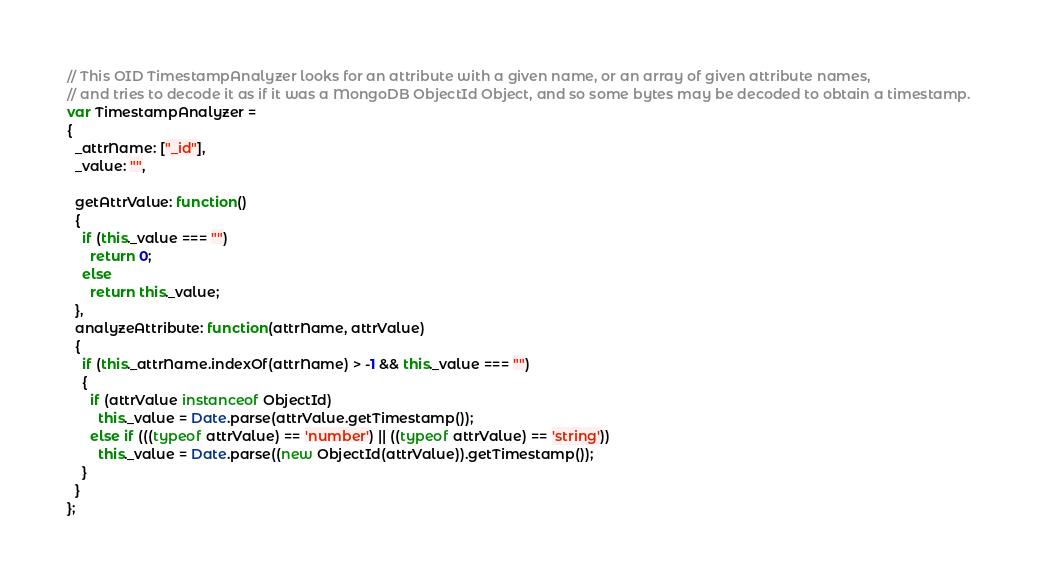Convert code to text. <code><loc_0><loc_0><loc_500><loc_500><_JavaScript_>// This OID TimestampAnalyzer looks for an attribute with a given name, or an array of given attribute names,
// and tries to decode it as if it was a MongoDB ObjectId Object, and so some bytes may be decoded to obtain a timestamp.
var TimestampAnalyzer =
{
  _attrName: ["_id"],
  _value: "",

  getAttrValue: function()
  {
    if (this._value === "")
      return 0;
    else
      return this._value;
  },
  analyzeAttribute: function(attrName, attrValue)
  {
    if (this._attrName.indexOf(attrName) > -1 && this._value === "")
    {
      if (attrValue instanceof ObjectId)
        this._value = Date.parse(attrValue.getTimestamp());
      else if (((typeof attrValue) == 'number') || ((typeof attrValue) == 'string'))
        this._value = Date.parse((new ObjectId(attrValue)).getTimestamp());
    }
  }
};
</code> 